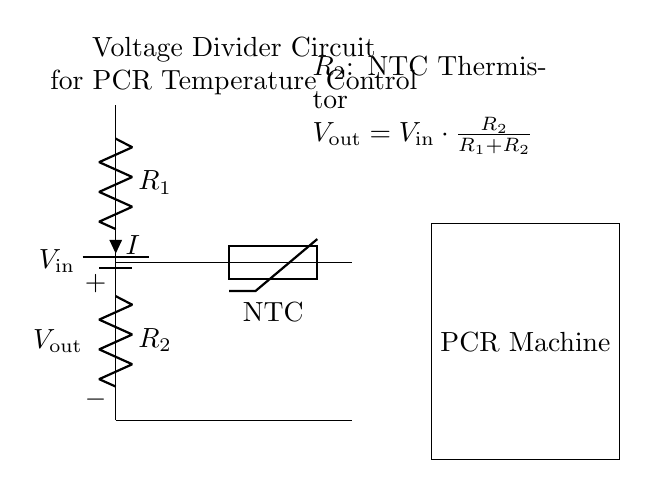What type of resistors are used in this circuit? The circuit contains resistors labeled R1 and R2, where R2 is specifically noted as a thermistor (NTC). Thus, R1 is a general resistor, and R2 is a thermistor that varies resistance based on temperature.
Answer: NTC thermistor and resistor What does V out represent in this circuit? V out stands for the output voltage, which is determined by the formula V out = V in * (R2 / (R1 + R2)). This indicates the voltage across R2 in relation to the total voltage and the resistances in the divider.
Answer: Output voltage Which component is responsible for sensing temperature? The temperature sensor in this circuit is the NTC thermistor, which changes resistance with temperature variations, affecting the output voltage and thus helping in temperature control.
Answer: NTC thermistor How does changing temperature affect V out? As temperature increases, an NTC thermistor's resistance decreases, leading to a higher V out according to the voltage divider formula. This is key to maintaining precise temperature control in the PCR machine.
Answer: Increase V out What is the relationship between R1 and R2 in determining output voltage? The output voltage is directly influenced by the ratio of R2 to the total resistance (R1 + R2) as described in the voltage divider formula, indicating that variations in either resistor will affect V out.
Answer: Voltage divider ratio What is the function of the battery in this circuit? The battery supplies the input voltage, V in, to the circuit, allowing the voltage divider to operate and produce a measurable output voltage V out based on the resistances.
Answer: Voltage supply 